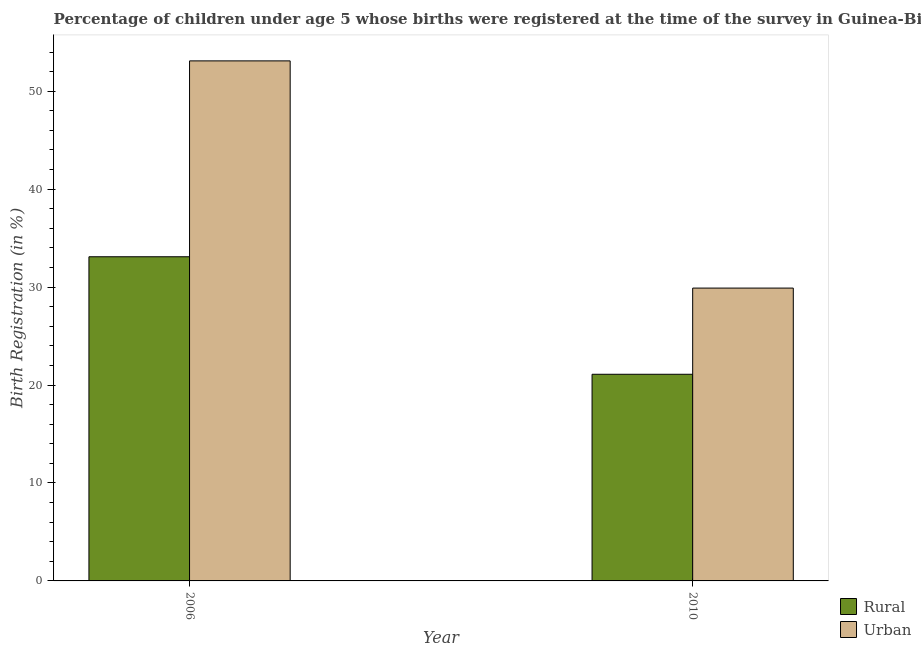Are the number of bars on each tick of the X-axis equal?
Make the answer very short. Yes. How many bars are there on the 2nd tick from the left?
Your response must be concise. 2. How many bars are there on the 1st tick from the right?
Keep it short and to the point. 2. What is the label of the 2nd group of bars from the left?
Provide a succinct answer. 2010. What is the rural birth registration in 2010?
Your answer should be compact. 21.1. Across all years, what is the maximum rural birth registration?
Provide a succinct answer. 33.1. Across all years, what is the minimum urban birth registration?
Offer a terse response. 29.9. In which year was the rural birth registration maximum?
Ensure brevity in your answer.  2006. What is the total urban birth registration in the graph?
Give a very brief answer. 83. What is the difference between the urban birth registration in 2006 and that in 2010?
Your response must be concise. 23.2. What is the average urban birth registration per year?
Your answer should be compact. 41.5. In how many years, is the rural birth registration greater than 44 %?
Give a very brief answer. 0. What is the ratio of the urban birth registration in 2006 to that in 2010?
Your answer should be compact. 1.78. Is the urban birth registration in 2006 less than that in 2010?
Keep it short and to the point. No. What does the 1st bar from the left in 2010 represents?
Make the answer very short. Rural. What does the 2nd bar from the right in 2010 represents?
Give a very brief answer. Rural. How many bars are there?
Your answer should be very brief. 4. Are all the bars in the graph horizontal?
Ensure brevity in your answer.  No. How many years are there in the graph?
Provide a succinct answer. 2. Does the graph contain any zero values?
Your answer should be compact. No. What is the title of the graph?
Ensure brevity in your answer.  Percentage of children under age 5 whose births were registered at the time of the survey in Guinea-Bissau. What is the label or title of the X-axis?
Provide a short and direct response. Year. What is the label or title of the Y-axis?
Make the answer very short. Birth Registration (in %). What is the Birth Registration (in %) of Rural in 2006?
Your response must be concise. 33.1. What is the Birth Registration (in %) of Urban in 2006?
Keep it short and to the point. 53.1. What is the Birth Registration (in %) in Rural in 2010?
Keep it short and to the point. 21.1. What is the Birth Registration (in %) of Urban in 2010?
Make the answer very short. 29.9. Across all years, what is the maximum Birth Registration (in %) of Rural?
Your answer should be very brief. 33.1. Across all years, what is the maximum Birth Registration (in %) in Urban?
Provide a short and direct response. 53.1. Across all years, what is the minimum Birth Registration (in %) of Rural?
Your response must be concise. 21.1. Across all years, what is the minimum Birth Registration (in %) of Urban?
Your answer should be compact. 29.9. What is the total Birth Registration (in %) in Rural in the graph?
Your response must be concise. 54.2. What is the total Birth Registration (in %) in Urban in the graph?
Make the answer very short. 83. What is the difference between the Birth Registration (in %) of Rural in 2006 and that in 2010?
Your answer should be very brief. 12. What is the difference between the Birth Registration (in %) of Urban in 2006 and that in 2010?
Keep it short and to the point. 23.2. What is the difference between the Birth Registration (in %) of Rural in 2006 and the Birth Registration (in %) of Urban in 2010?
Your answer should be very brief. 3.2. What is the average Birth Registration (in %) of Rural per year?
Make the answer very short. 27.1. What is the average Birth Registration (in %) of Urban per year?
Provide a short and direct response. 41.5. In the year 2006, what is the difference between the Birth Registration (in %) of Rural and Birth Registration (in %) of Urban?
Provide a succinct answer. -20. What is the ratio of the Birth Registration (in %) in Rural in 2006 to that in 2010?
Your answer should be compact. 1.57. What is the ratio of the Birth Registration (in %) of Urban in 2006 to that in 2010?
Your answer should be compact. 1.78. What is the difference between the highest and the second highest Birth Registration (in %) of Rural?
Ensure brevity in your answer.  12. What is the difference between the highest and the second highest Birth Registration (in %) of Urban?
Offer a very short reply. 23.2. What is the difference between the highest and the lowest Birth Registration (in %) in Rural?
Your response must be concise. 12. What is the difference between the highest and the lowest Birth Registration (in %) in Urban?
Provide a succinct answer. 23.2. 